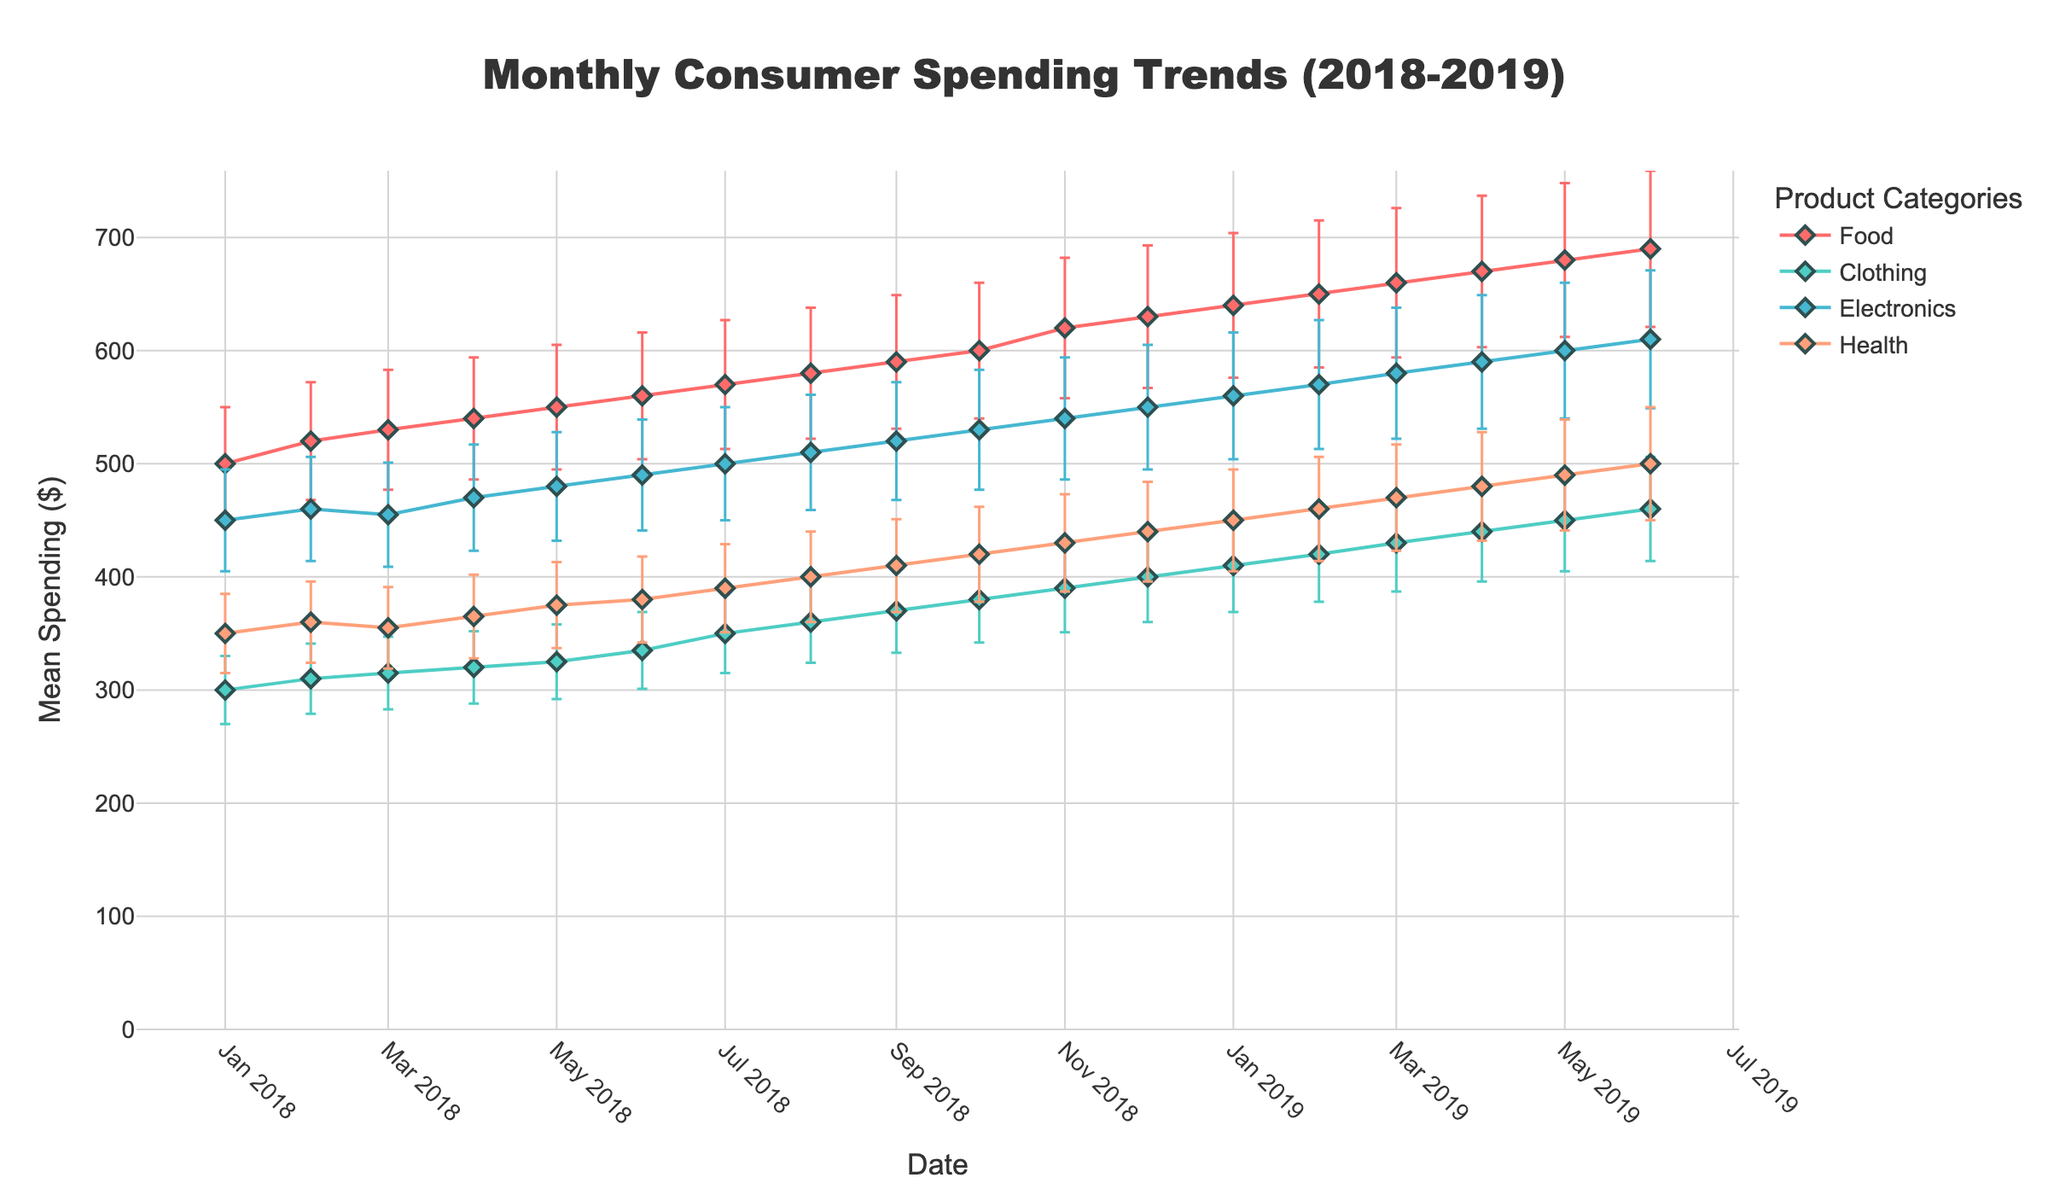What is the overall trend in consumer spending on Food from 2018 to 2019? The trend for consumer spending on Food shows a steady increase over the two-year period. Starting from around $500 in January 2018, it reaches about $690 by June 2019.
Answer: Steady increase How does the spending on Electronics in January 2018 compare to January 2019? In January 2018, the spending on Electronics is around $450. By January 2019, it has increased to about $560, indicating a rise in spending over the year.
Answer: Increased Which category had the highest mean spending in December 2018? The category with the highest mean spending in December 2018 is Food, with spending reaching about $630.
Answer: Food How does the error margin for Health spending in February 2019 compare to that in February 2018? The error margin for Health spending in February 2019 is $46, while in February 2018, it is $36. By comparing these values, we see that the error margin has increased by $10.
Answer: Increased by $10 What is the mean spending on Clothing in June 2019 and how does it compare to June 2018? In June 2019, the mean spending on Clothing is about $460, whereas in June 2018, it is approximately $335. The spending has therefore increased by $125 over this period.
Answer: Increased by $125 Of the four categories, which one consistently shows the least mean spending throughout the observed period? Clothing consistently shows the least mean spending throughout the period, with monthly spending values typically being lower compared to the other categories.
Answer: Clothing If you were to add the mean spending on Electronics and Health in July 2018, what would be the sum? The mean spending on Electronics in July 2018 is $500, and for Health, it is $390. Adding these gives 500 + 390 = $890.
Answer: $890 Which month and year saw the largest error margin in any category, and which category was it? December 2018 saw the largest error margin in any category, which was $63 for the Food category.
Answer: December 2018, Food How does the spending trend for Electronics compare to the trend for Health over the observed period? Both the Electronics and Health categories show a generally increasing trend over the observed period. However, Electronics starts from a higher base and ends at a higher mean spending level compared to Health.
Answer: Both increasing, Electronics higher In which month of the first quarter of 2018 did the spending on Clothing see the highest mean, and what was the amount? In March 2018, the spending on Clothing reached its highest mean for the first quarter of 2018, with an amount of $315.
Answer: March 2018, $315 